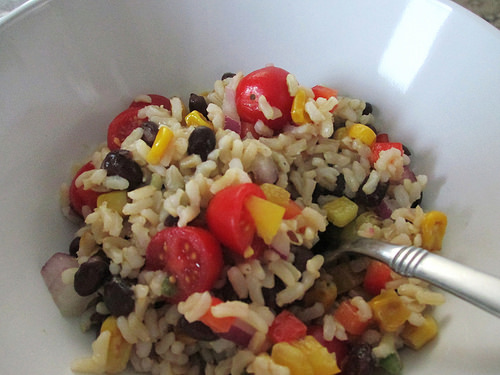<image>
Is the tomato on the rice? Yes. Looking at the image, I can see the tomato is positioned on top of the rice, with the rice providing support. Is there a fork in the tomato? No. The fork is not contained within the tomato. These objects have a different spatial relationship. 